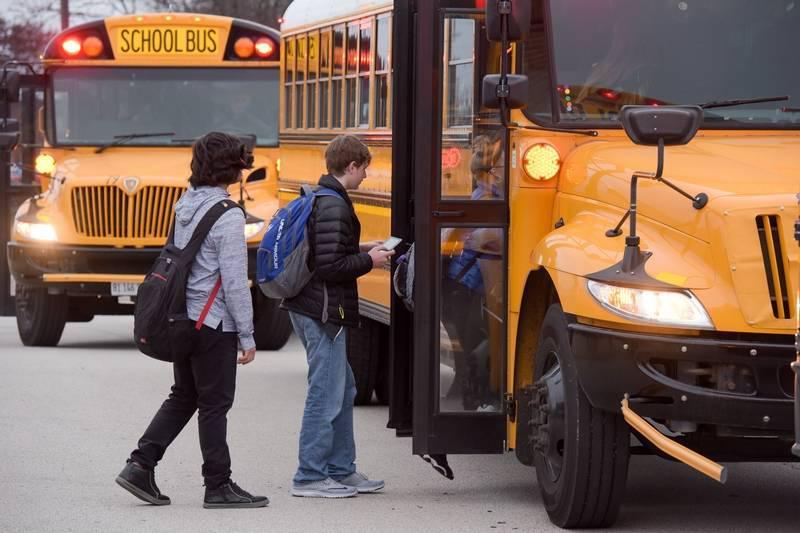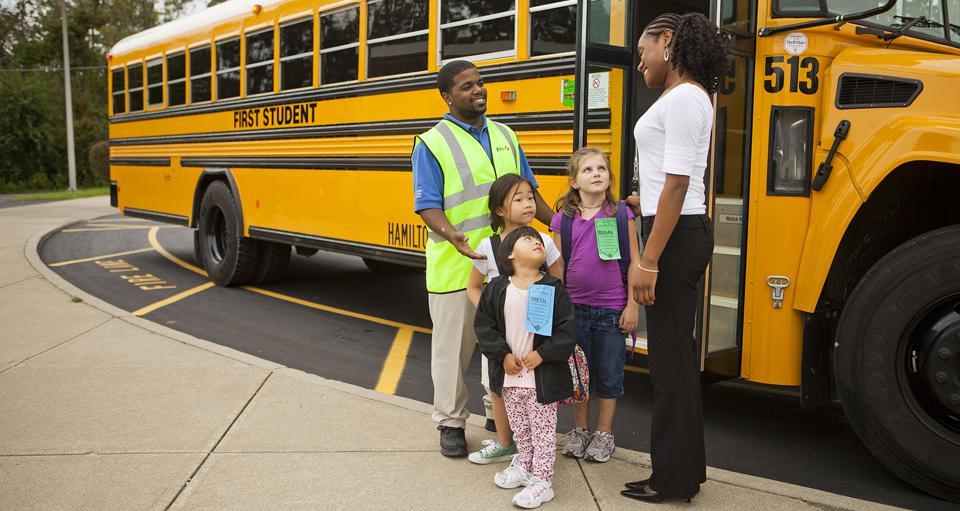The first image is the image on the left, the second image is the image on the right. Given the left and right images, does the statement "The right image includes at least one adult and at least two young children by the open doors of a bus parked diagonally facing right, and the left image shows at least two teens with backpacks to the left of a bus with an open door." hold true? Answer yes or no. Yes. 